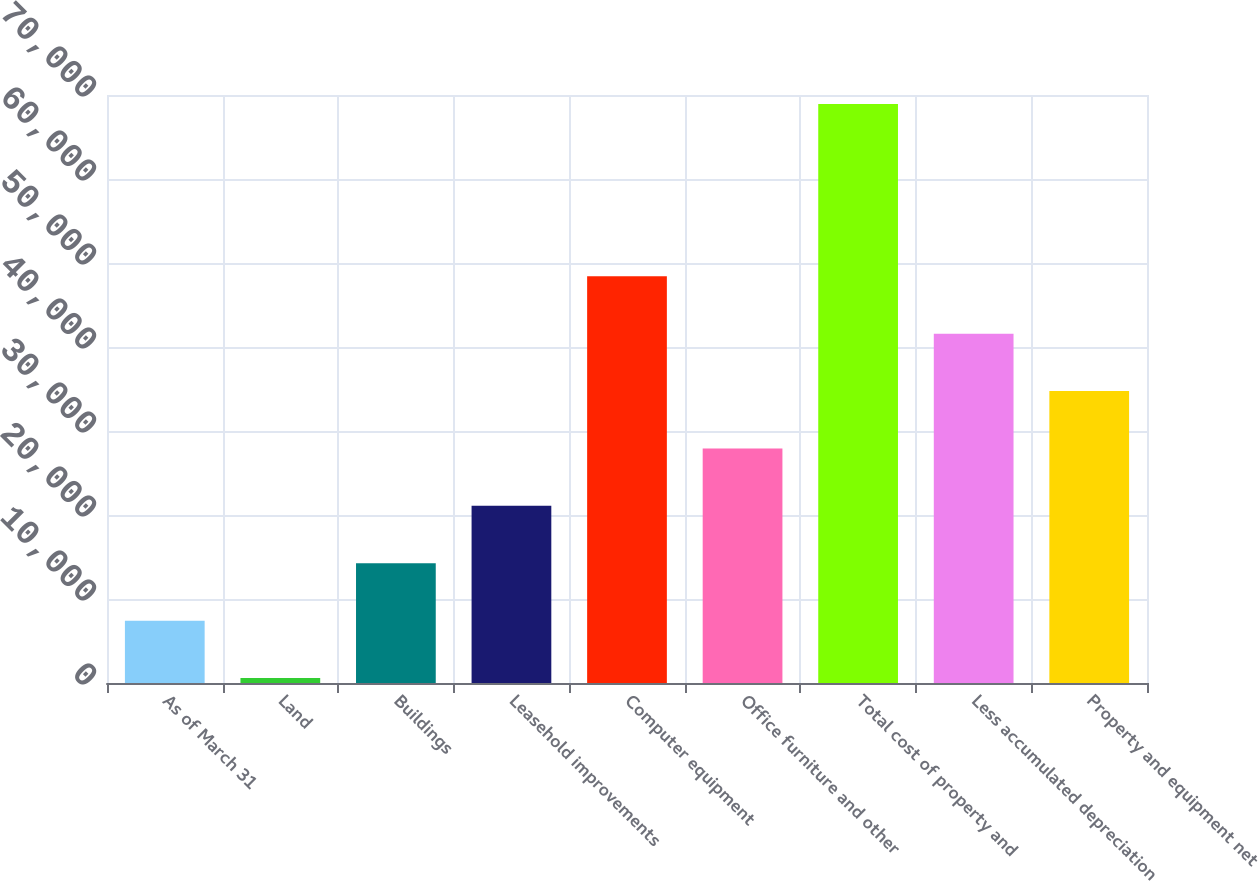Convert chart to OTSL. <chart><loc_0><loc_0><loc_500><loc_500><bar_chart><fcel>As of March 31<fcel>Land<fcel>Buildings<fcel>Leasehold improvements<fcel>Computer equipment<fcel>Office furniture and other<fcel>Total cost of property and<fcel>Less accumulated depreciation<fcel>Property and equipment net<nl><fcel>7425.1<fcel>592<fcel>14258.2<fcel>21091.3<fcel>48423.7<fcel>27924.4<fcel>68923<fcel>41590.6<fcel>34757.5<nl></chart> 